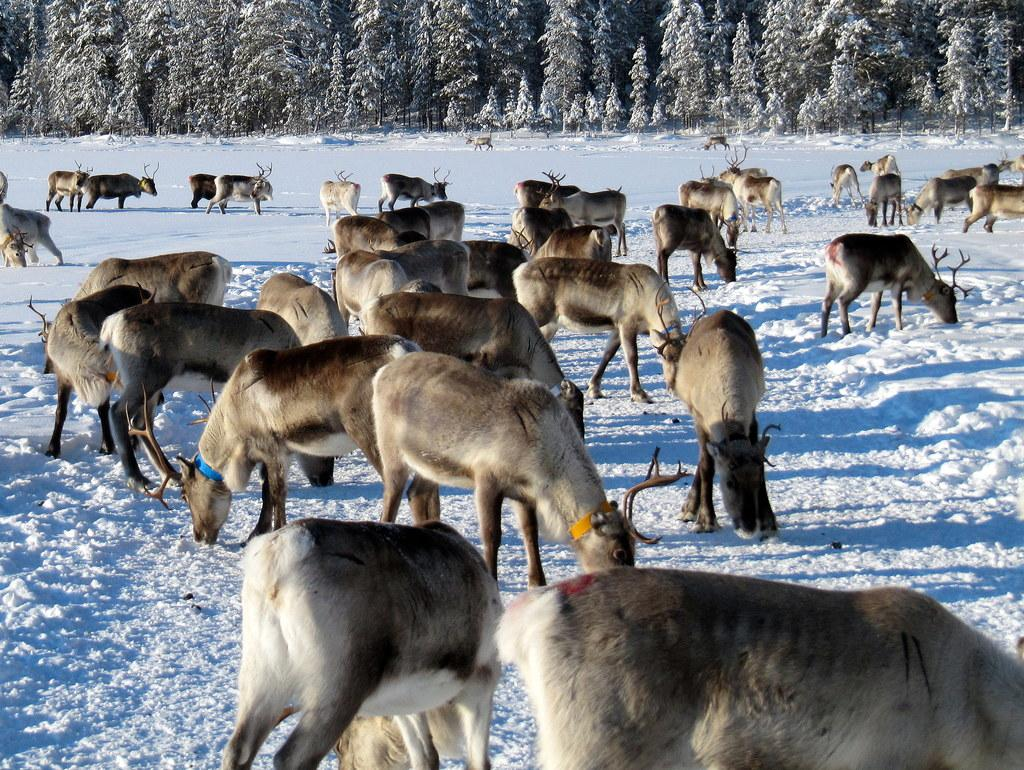What type of environment is depicted in the image? The image is taken in a forest. What animals can be seen in the foreground of the image? There are antelopes in the foreground of the image. What is the ground condition in the foreground of the image? There is snow in the foreground of the image. What can be seen in the background of the image? There are trees in the background of the image. What is the weather like in the image? It is sunny in the image. What type of operation is being performed on the antelope in the image? There is no operation being performed on the antelope in the image; it is simply standing in the snow. What drug is being administered to the antelope in the image? There is no drug being administered to the antelope in the image; it is not interacting with any humans or objects. 